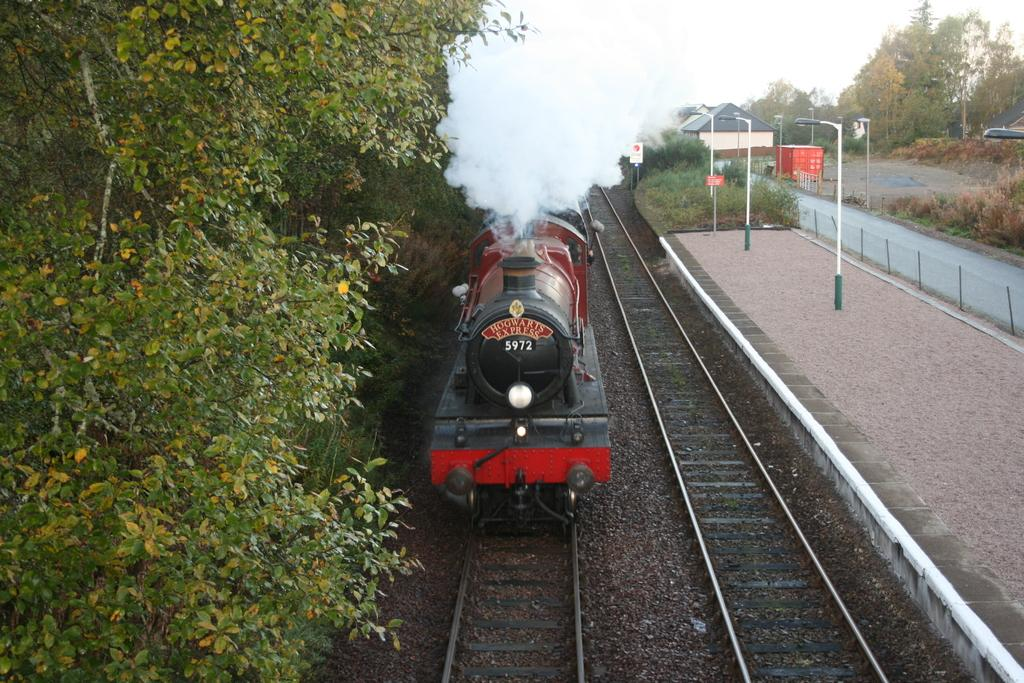What is the main subject of the image? The main subject of the image is a train on the railway tracks. What can be seen in the background of the image? In the background of the image, there are railway tracks, trees, a platform, boards, lights, poles, a building, grass, and the sky. Can you describe the setting of the image? The image is set in a railway station or a similar environment, with a train on the tracks and various structures and elements in the background. Where is the nest of the bird located in the image? There is no nest or bird present in the image. What type of club can be seen in the image? There is no club visible in the image. 